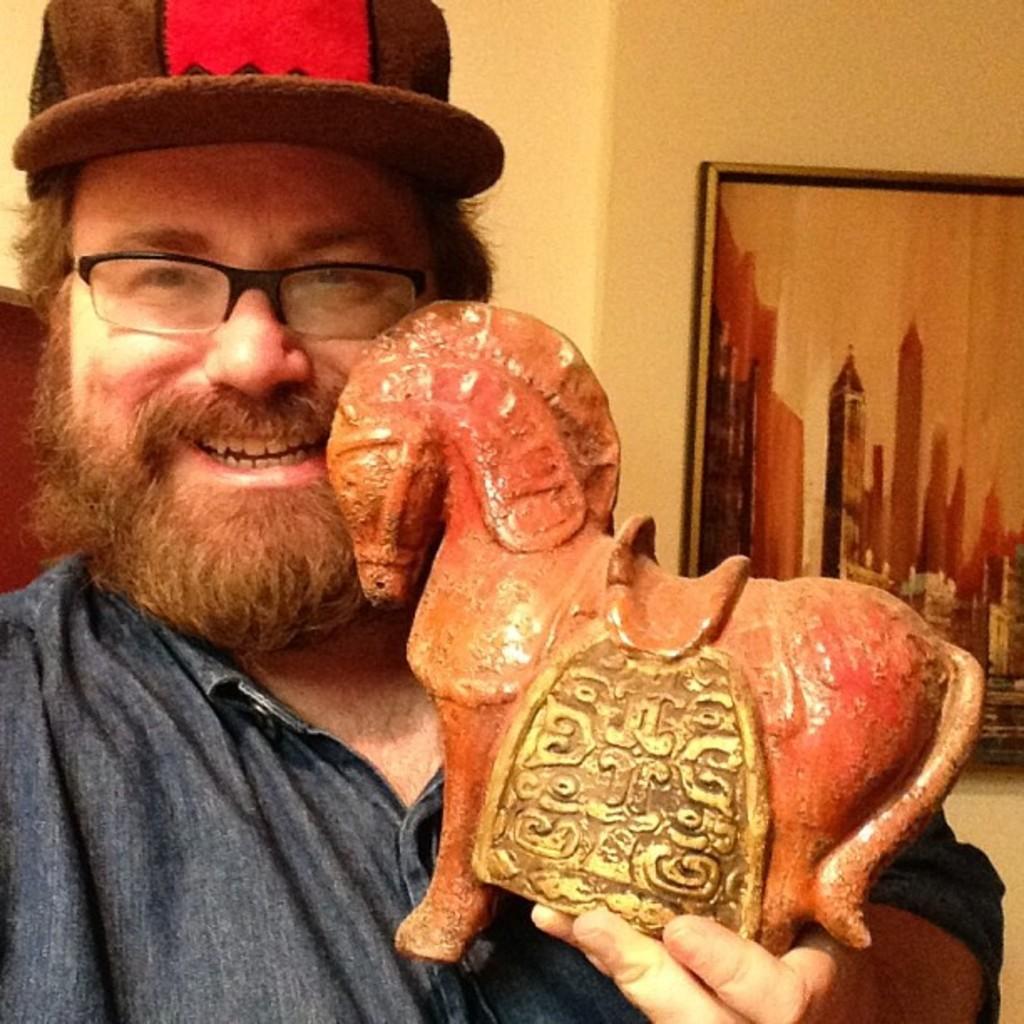Can you describe this image briefly? In this image I can see a person holding horse toy. He is wearing cap. The frame is attached to the cream color wall. 